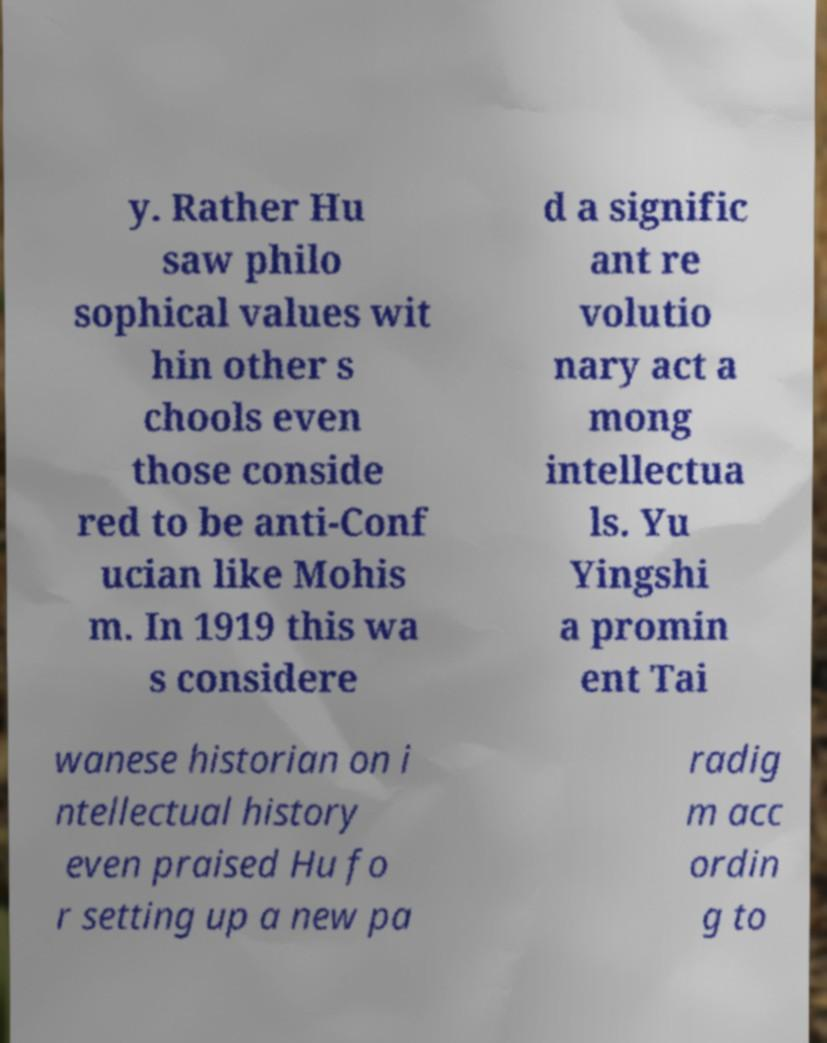Please read and relay the text visible in this image. What does it say? y. Rather Hu saw philo sophical values wit hin other s chools even those conside red to be anti-Conf ucian like Mohis m. In 1919 this wa s considere d a signific ant re volutio nary act a mong intellectua ls. Yu Yingshi a promin ent Tai wanese historian on i ntellectual history even praised Hu fo r setting up a new pa radig m acc ordin g to 